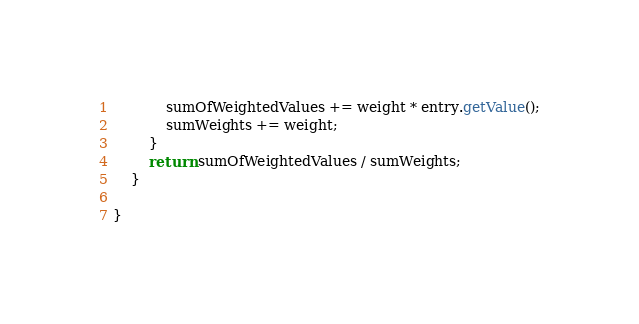Convert code to text. <code><loc_0><loc_0><loc_500><loc_500><_Java_>            sumOfWeightedValues += weight * entry.getValue();
            sumWeights += weight;
        }
        return sumOfWeightedValues / sumWeights;
    }

}
</code> 